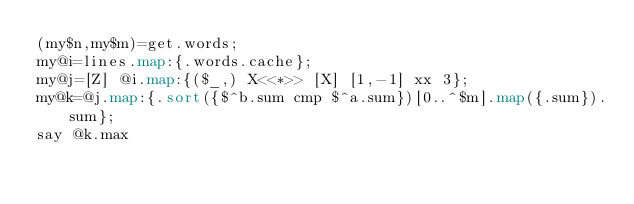Convert code to text. <code><loc_0><loc_0><loc_500><loc_500><_Perl_>(my$n,my$m)=get.words;
my@i=lines.map:{.words.cache};
my@j=[Z] @i.map:{($_,) X<<*>> [X] [1,-1] xx 3};
my@k=@j.map:{.sort({$^b.sum cmp $^a.sum})[0..^$m].map({.sum}).sum};
say @k.max
</code> 